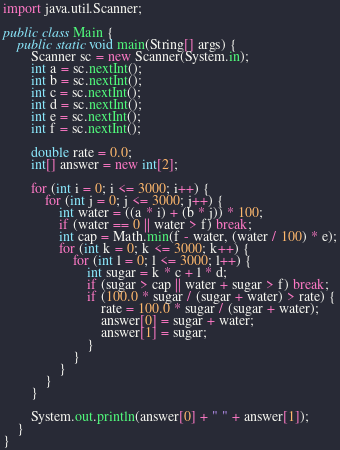<code> <loc_0><loc_0><loc_500><loc_500><_Java_>import java.util.Scanner;

public class Main {
	public static void main(String[] args) {
		Scanner sc = new Scanner(System.in);
		int a = sc.nextInt();
		int b = sc.nextInt();
		int c = sc.nextInt();
		int d = sc.nextInt();
		int e = sc.nextInt();
		int f = sc.nextInt();

		double rate = 0.0;
		int[] answer = new int[2];

		for (int i = 0; i <= 3000; i++) {
			for (int j = 0; j <= 3000; j++) {
				int water = ((a * i) + (b * j)) * 100;
				if (water == 0 || water > f) break;
				int cap = Math.min(f - water, (water / 100) * e);
				for (int k = 0; k <= 3000; k++) {
					for (int l = 0; l <= 3000; l++) {
						int sugar = k * c + l * d;
						if (sugar > cap || water + sugar > f) break;
						if (100.0 * sugar / (sugar + water) > rate) {
							rate = 100.0 * sugar / (sugar + water);
							answer[0] = sugar + water;
							answer[1] = sugar;
						}
					}
				}
			}
		}

		System.out.println(answer[0] + " " + answer[1]);
	}
}
</code> 